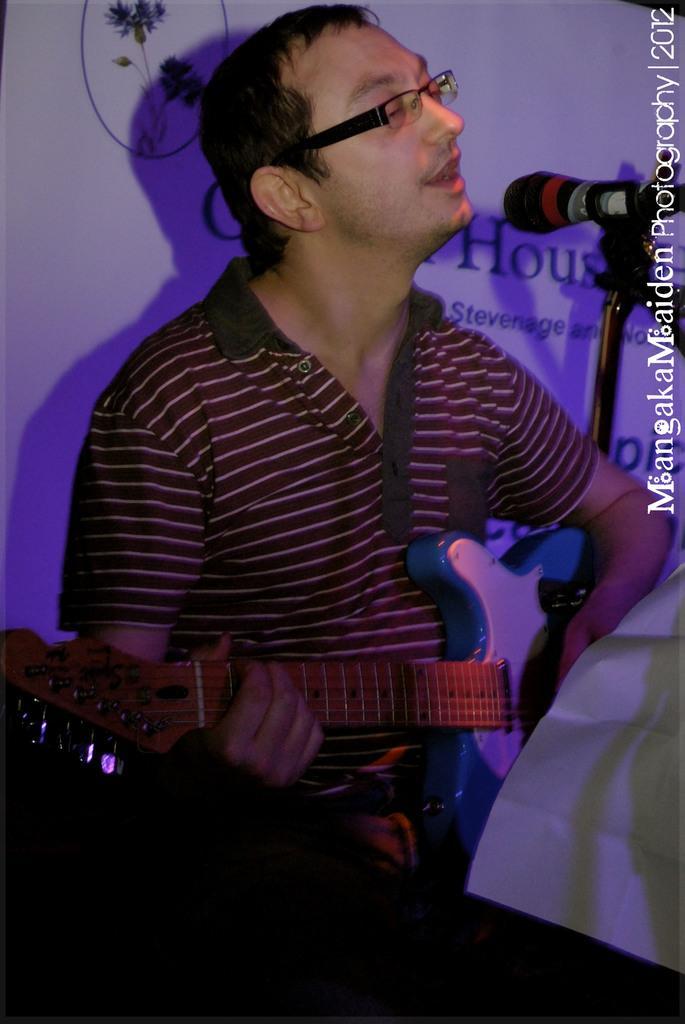Describe this image in one or two sentences. Here we can see that a person is sitting and holding guitar in his hands and he is singing, and in front here is the microphone and at back here is the banner. 